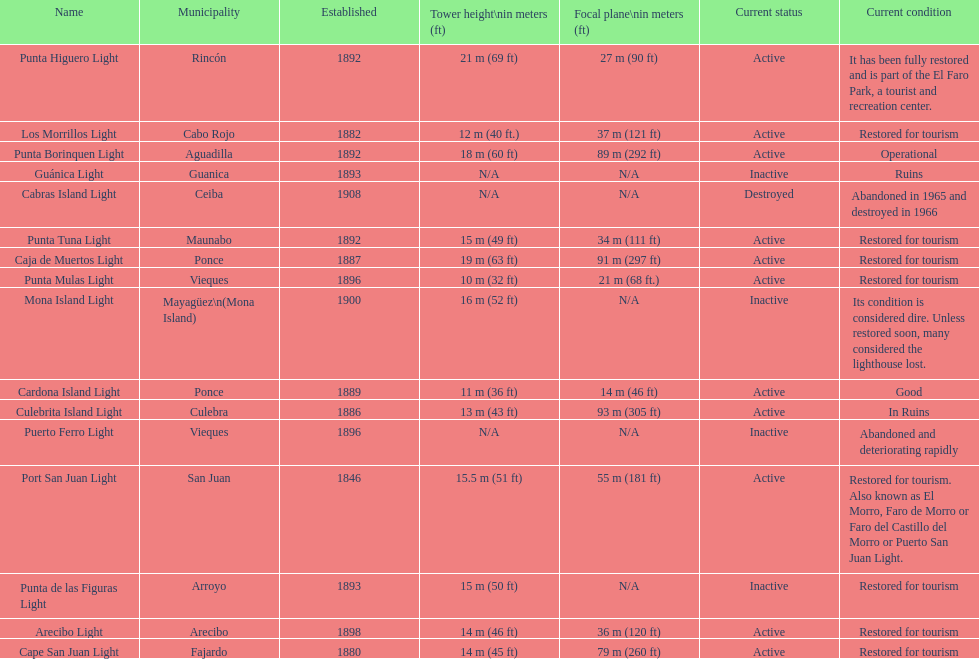Which local government area was the first to be created? San Juan. 